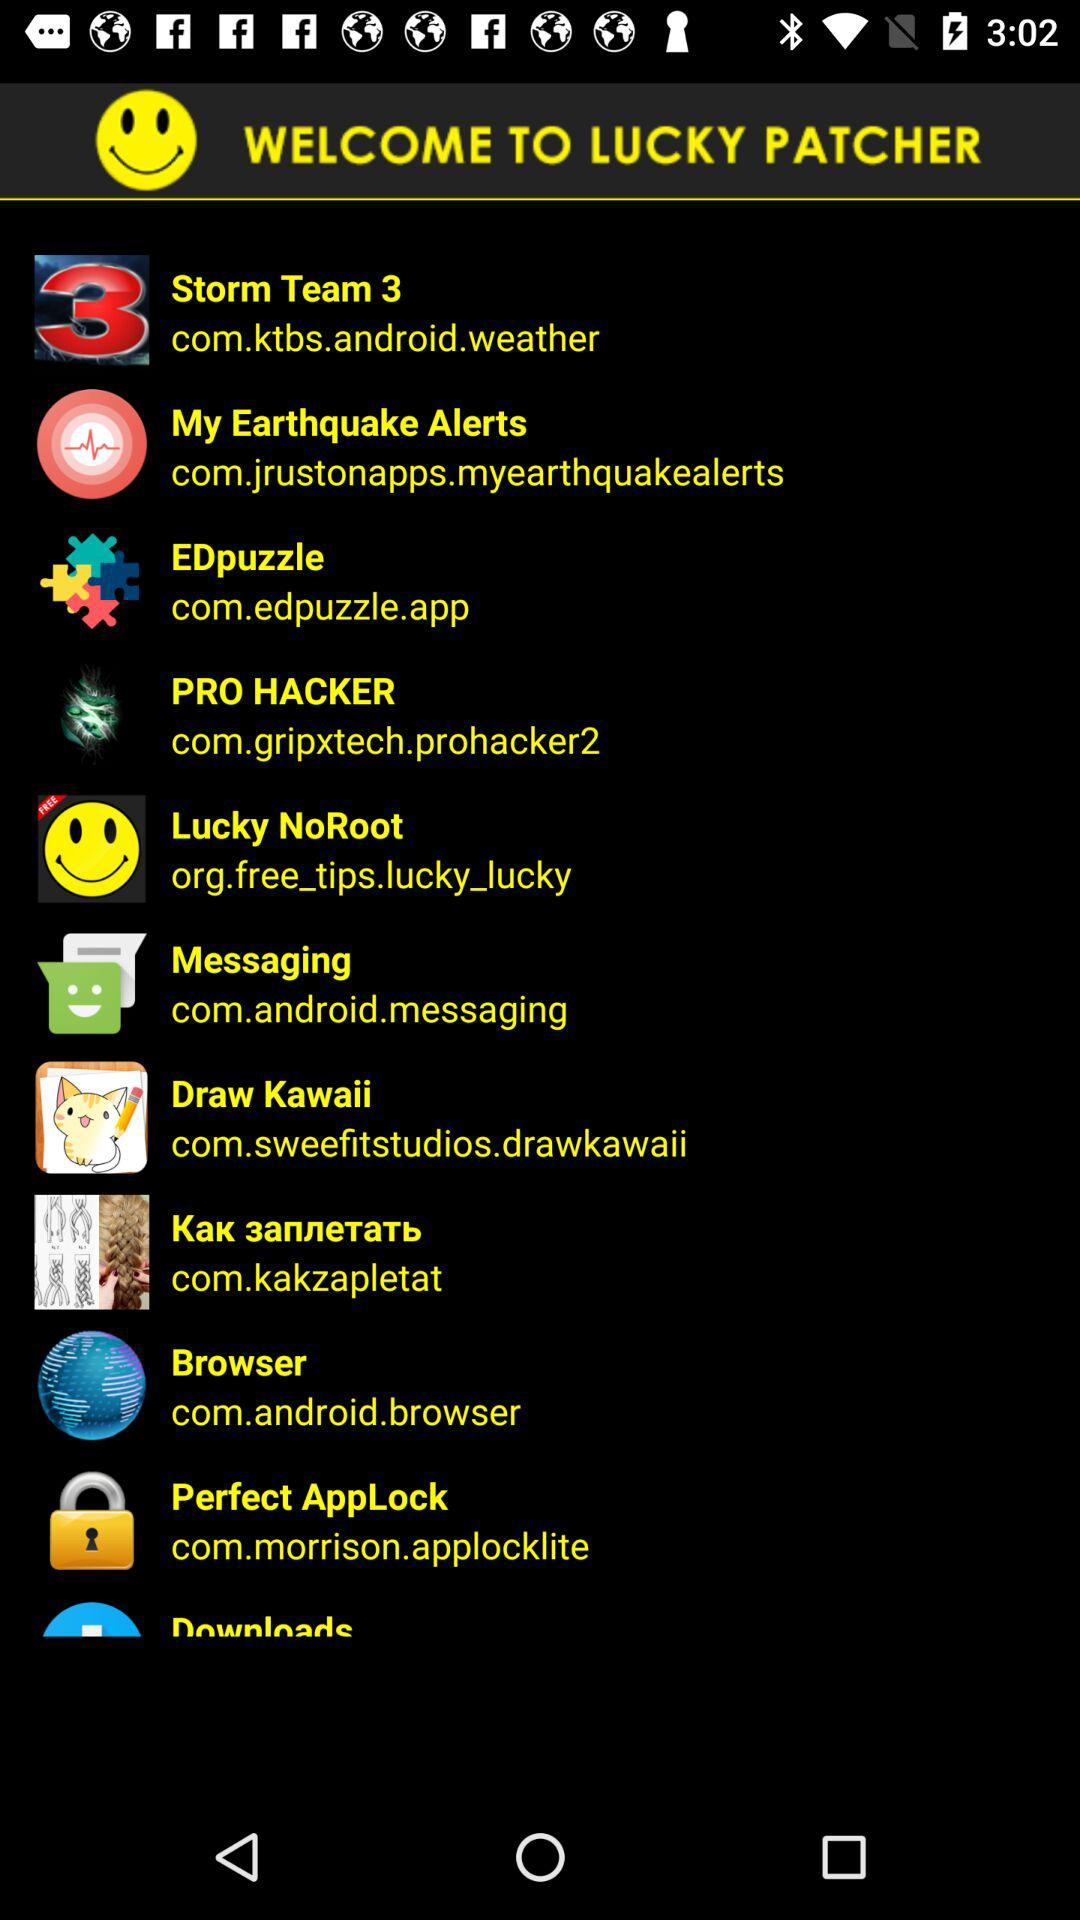What application is the site com.edpuzzle.app given for? The application is "EDpuzzle". 